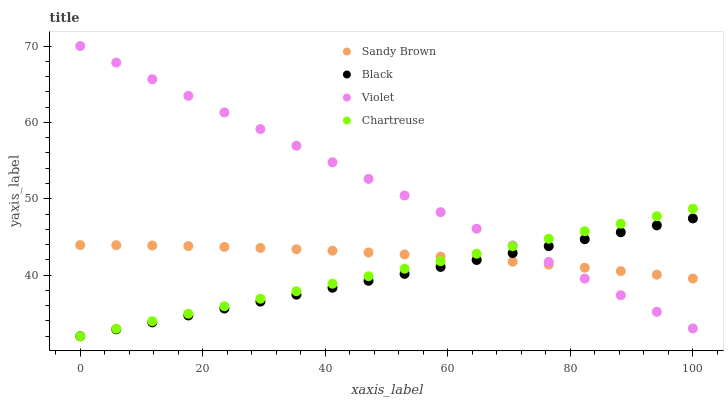Does Black have the minimum area under the curve?
Answer yes or no. Yes. Does Violet have the maximum area under the curve?
Answer yes or no. Yes. Does Chartreuse have the minimum area under the curve?
Answer yes or no. No. Does Chartreuse have the maximum area under the curve?
Answer yes or no. No. Is Chartreuse the smoothest?
Answer yes or no. Yes. Is Sandy Brown the roughest?
Answer yes or no. Yes. Is Sandy Brown the smoothest?
Answer yes or no. No. Is Chartreuse the roughest?
Answer yes or no. No. Does Black have the lowest value?
Answer yes or no. Yes. Does Sandy Brown have the lowest value?
Answer yes or no. No. Does Violet have the highest value?
Answer yes or no. Yes. Does Chartreuse have the highest value?
Answer yes or no. No. Does Sandy Brown intersect Violet?
Answer yes or no. Yes. Is Sandy Brown less than Violet?
Answer yes or no. No. Is Sandy Brown greater than Violet?
Answer yes or no. No. 